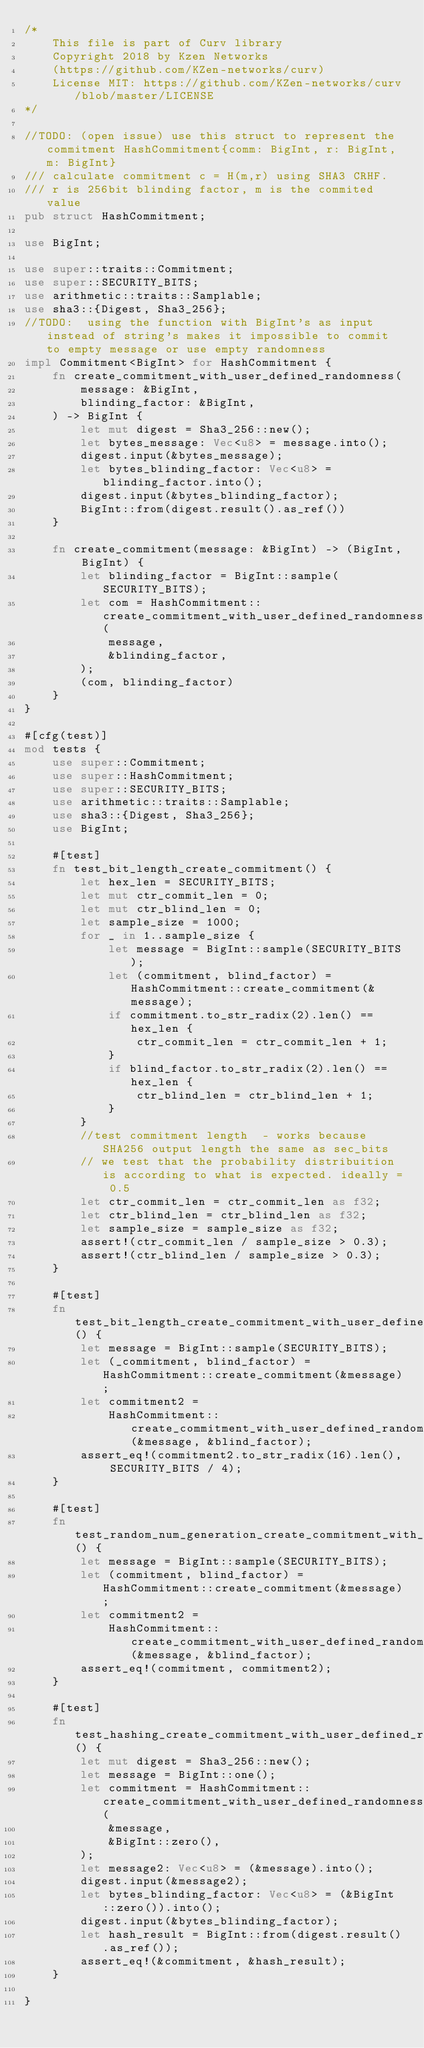Convert code to text. <code><loc_0><loc_0><loc_500><loc_500><_Rust_>/*
    This file is part of Curv library
    Copyright 2018 by Kzen Networks
    (https://github.com/KZen-networks/curv)
    License MIT: https://github.com/KZen-networks/curv/blob/master/LICENSE
*/

//TODO: (open issue) use this struct to represent the commitment HashCommitment{comm: BigInt, r: BigInt, m: BigInt}
/// calculate commitment c = H(m,r) using SHA3 CRHF.
/// r is 256bit blinding factor, m is the commited value
pub struct HashCommitment;

use BigInt;

use super::traits::Commitment;
use super::SECURITY_BITS;
use arithmetic::traits::Samplable;
use sha3::{Digest, Sha3_256};
//TODO:  using the function with BigInt's as input instead of string's makes it impossible to commit to empty message or use empty randomness
impl Commitment<BigInt> for HashCommitment {
    fn create_commitment_with_user_defined_randomness(
        message: &BigInt,
        blinding_factor: &BigInt,
    ) -> BigInt {
        let mut digest = Sha3_256::new();
        let bytes_message: Vec<u8> = message.into();
        digest.input(&bytes_message);
        let bytes_blinding_factor: Vec<u8> = blinding_factor.into();
        digest.input(&bytes_blinding_factor);
        BigInt::from(digest.result().as_ref())
    }

    fn create_commitment(message: &BigInt) -> (BigInt, BigInt) {
        let blinding_factor = BigInt::sample(SECURITY_BITS);
        let com = HashCommitment::create_commitment_with_user_defined_randomness(
            message,
            &blinding_factor,
        );
        (com, blinding_factor)
    }
}

#[cfg(test)]
mod tests {
    use super::Commitment;
    use super::HashCommitment;
    use super::SECURITY_BITS;
    use arithmetic::traits::Samplable;
    use sha3::{Digest, Sha3_256};
    use BigInt;

    #[test]
    fn test_bit_length_create_commitment() {
        let hex_len = SECURITY_BITS;
        let mut ctr_commit_len = 0;
        let mut ctr_blind_len = 0;
        let sample_size = 1000;
        for _ in 1..sample_size {
            let message = BigInt::sample(SECURITY_BITS);
            let (commitment, blind_factor) = HashCommitment::create_commitment(&message);
            if commitment.to_str_radix(2).len() == hex_len {
                ctr_commit_len = ctr_commit_len + 1;
            }
            if blind_factor.to_str_radix(2).len() == hex_len {
                ctr_blind_len = ctr_blind_len + 1;
            }
        }
        //test commitment length  - works because SHA256 output length the same as sec_bits
        // we test that the probability distribuition is according to what is expected. ideally = 0.5
        let ctr_commit_len = ctr_commit_len as f32;
        let ctr_blind_len = ctr_blind_len as f32;
        let sample_size = sample_size as f32;
        assert!(ctr_commit_len / sample_size > 0.3);
        assert!(ctr_blind_len / sample_size > 0.3);
    }

    #[test]
    fn test_bit_length_create_commitment_with_user_defined_randomness() {
        let message = BigInt::sample(SECURITY_BITS);
        let (_commitment, blind_factor) = HashCommitment::create_commitment(&message);
        let commitment2 =
            HashCommitment::create_commitment_with_user_defined_randomness(&message, &blind_factor);
        assert_eq!(commitment2.to_str_radix(16).len(), SECURITY_BITS / 4);
    }

    #[test]
    fn test_random_num_generation_create_commitment_with_user_defined_randomness() {
        let message = BigInt::sample(SECURITY_BITS);
        let (commitment, blind_factor) = HashCommitment::create_commitment(&message);
        let commitment2 =
            HashCommitment::create_commitment_with_user_defined_randomness(&message, &blind_factor);
        assert_eq!(commitment, commitment2);
    }

    #[test]
    fn test_hashing_create_commitment_with_user_defined_randomness() {
        let mut digest = Sha3_256::new();
        let message = BigInt::one();
        let commitment = HashCommitment::create_commitment_with_user_defined_randomness(
            &message,
            &BigInt::zero(),
        );
        let message2: Vec<u8> = (&message).into();
        digest.input(&message2);
        let bytes_blinding_factor: Vec<u8> = (&BigInt::zero()).into();
        digest.input(&bytes_blinding_factor);
        let hash_result = BigInt::from(digest.result().as_ref());
        assert_eq!(&commitment, &hash_result);
    }

}
</code> 